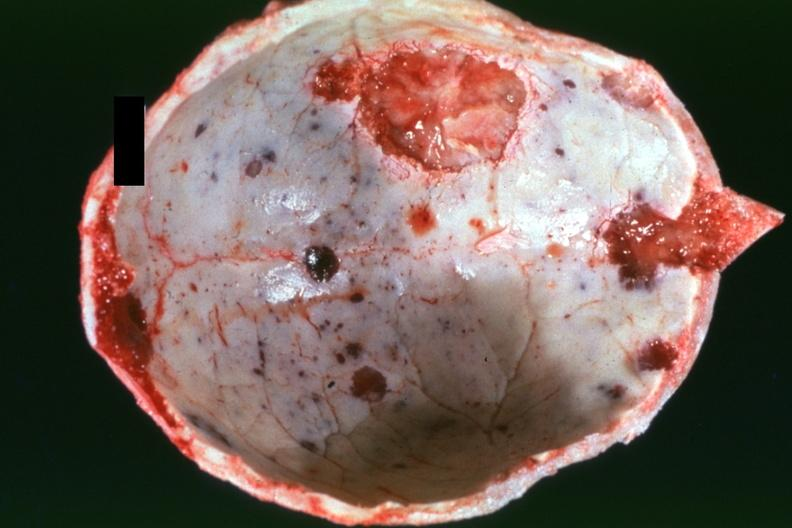s multiple myeloma present?
Answer the question using a single word or phrase. Yes 